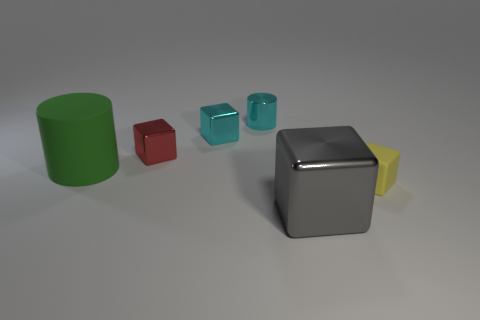How many other objects are there of the same shape as the tiny yellow rubber thing?
Your answer should be very brief. 3. There is a big thing in front of the tiny yellow cube; does it have the same shape as the tiny matte object?
Offer a very short reply. Yes. There is a tiny yellow cube; are there any matte things in front of it?
Offer a very short reply. No. How many tiny objects are green matte objects or blue rubber cylinders?
Your answer should be very brief. 0. Are the red cube and the large green cylinder made of the same material?
Give a very brief answer. No. The cube that is the same color as the small cylinder is what size?
Your response must be concise. Small. Is there a metallic cube of the same color as the large rubber cylinder?
Ensure brevity in your answer.  No. The red cube that is made of the same material as the cyan cylinder is what size?
Make the answer very short. Small. The big thing in front of the large object that is behind the metal object in front of the small red metal object is what shape?
Keep it short and to the point. Cube. What is the size of the cyan metal thing that is the same shape as the gray object?
Keep it short and to the point. Small. 